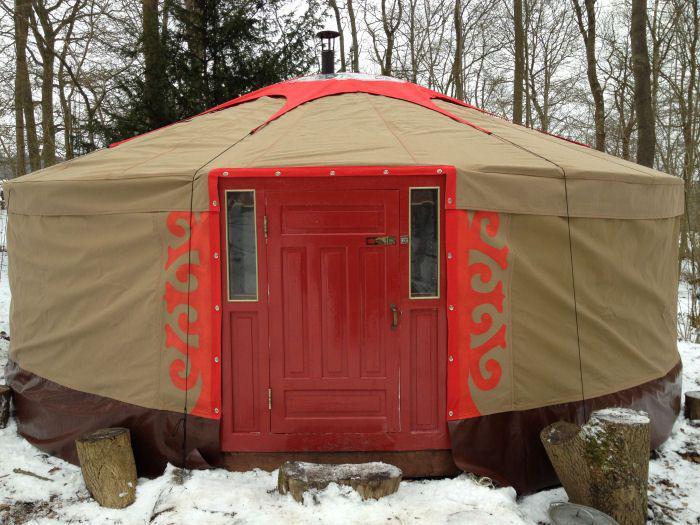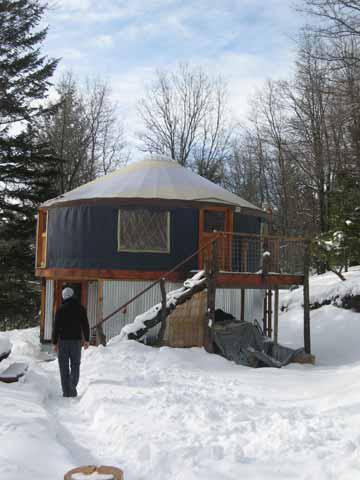The first image is the image on the left, the second image is the image on the right. Considering the images on both sides, is "An image shows side-by-side joined structures, both with cone/dome tops." valid? Answer yes or no. No. The first image is the image on the left, the second image is the image on the right. Assess this claim about the two images: "Two round houses are sitting in snowy areas.". Correct or not? Answer yes or no. Yes. 